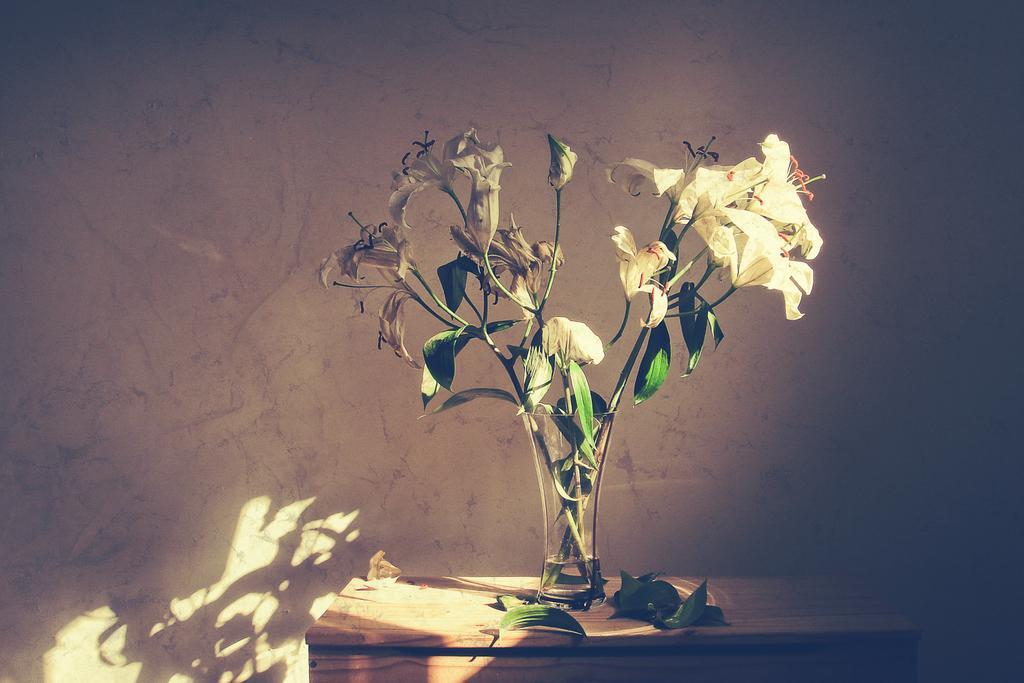In one or two sentences, can you explain what this image depicts? In this image there is a table and we can see a flower vase placed on the table. There are leaves on the table. In the background there is a wall. 